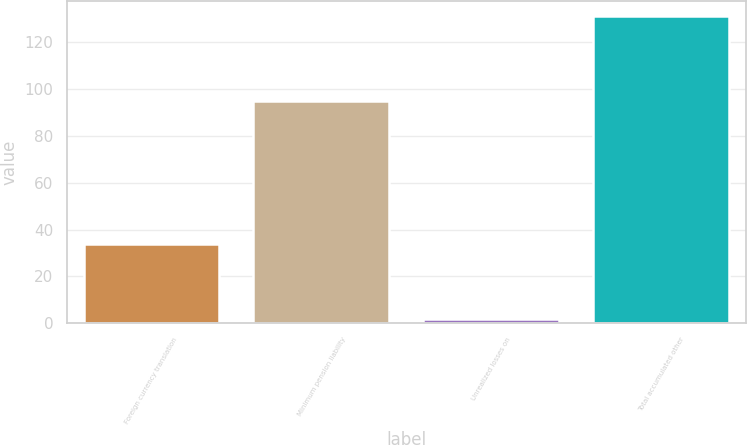Convert chart. <chart><loc_0><loc_0><loc_500><loc_500><bar_chart><fcel>Foreign currency translation<fcel>Minimum pension liability<fcel>Unrealized losses on<fcel>Total accumulated other<nl><fcel>34<fcel>95<fcel>2<fcel>131<nl></chart> 